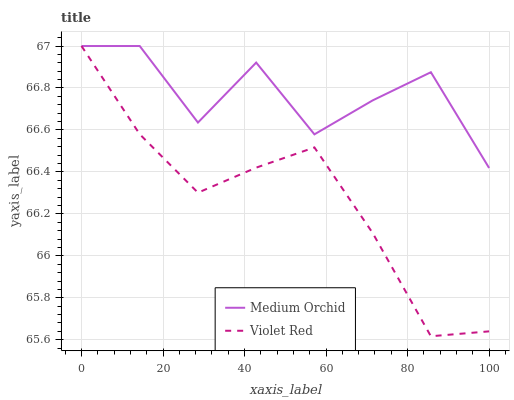Does Violet Red have the minimum area under the curve?
Answer yes or no. Yes. Does Medium Orchid have the maximum area under the curve?
Answer yes or no. Yes. Does Medium Orchid have the minimum area under the curve?
Answer yes or no. No. Is Violet Red the smoothest?
Answer yes or no. Yes. Is Medium Orchid the roughest?
Answer yes or no. Yes. Is Medium Orchid the smoothest?
Answer yes or no. No. Does Medium Orchid have the lowest value?
Answer yes or no. No. Does Medium Orchid have the highest value?
Answer yes or no. Yes. Does Violet Red intersect Medium Orchid?
Answer yes or no. Yes. Is Violet Red less than Medium Orchid?
Answer yes or no. No. Is Violet Red greater than Medium Orchid?
Answer yes or no. No. 